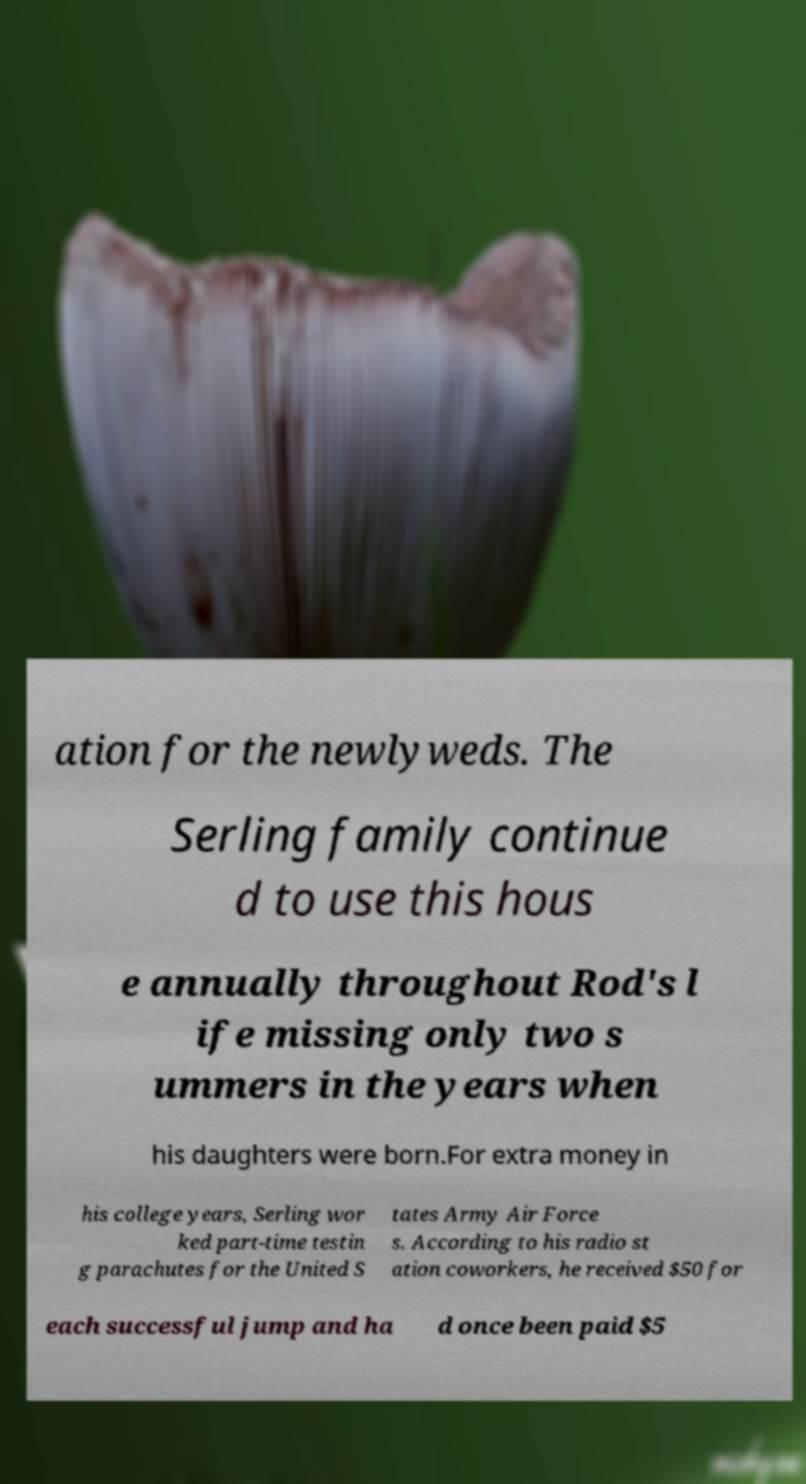Could you extract and type out the text from this image? ation for the newlyweds. The Serling family continue d to use this hous e annually throughout Rod's l ife missing only two s ummers in the years when his daughters were born.For extra money in his college years, Serling wor ked part-time testin g parachutes for the United S tates Army Air Force s. According to his radio st ation coworkers, he received $50 for each successful jump and ha d once been paid $5 